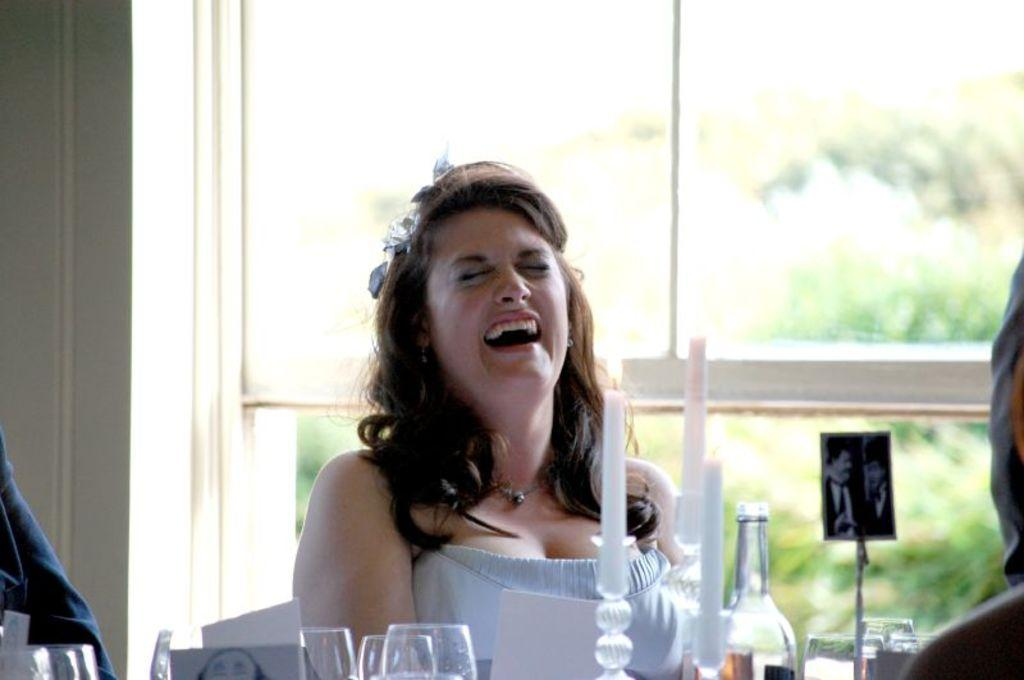Who is present in the image? There is a woman in the image. What is the woman doing in the image? The woman is laughing. What objects can be seen in the image? There are glasses, a bottle, candles, and other objects in the image. Can you describe the background of the image? There is a glass and a wall in the background of the image, with trees visible through the glass. What type of soap is being used by the woman in the image? There is no soap present in the image, as it features a woman laughing with various objects around her. 